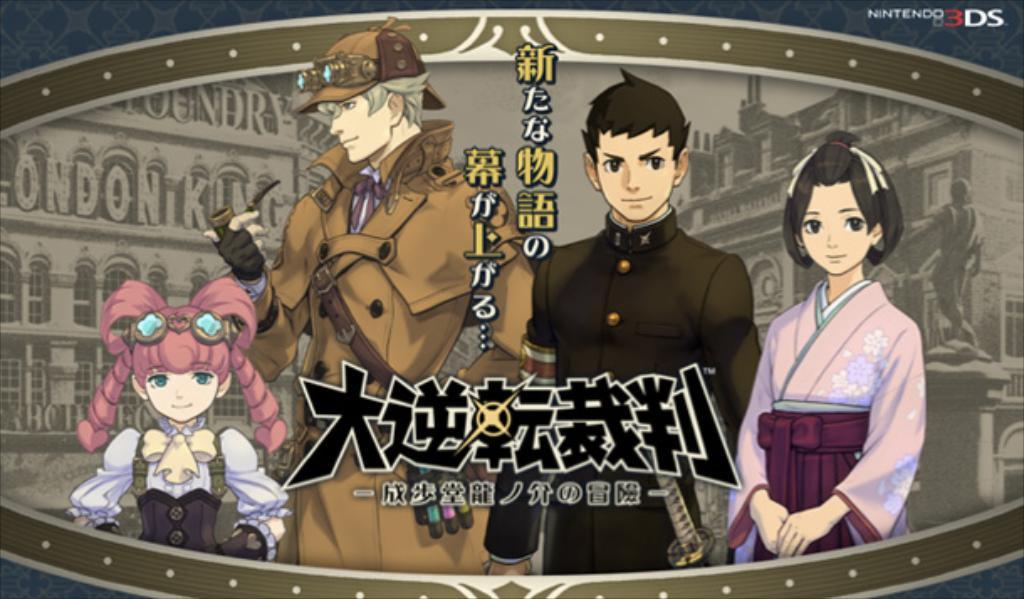What is depicted on the poster in the image? There is a poster with animated characters in the image. What else can be seen on the poster besides the animated characters? There is text on the poster. What type of background is visible behind the animated characters? There are buildings visible behind the animated characters. What other object can be seen in the image? There is a statue in the image. What type of nut is being used as a prop on the stage in the image? There is no stage or nut present in the image; it features a poster with animated characters, text, buildings, and a statue. 